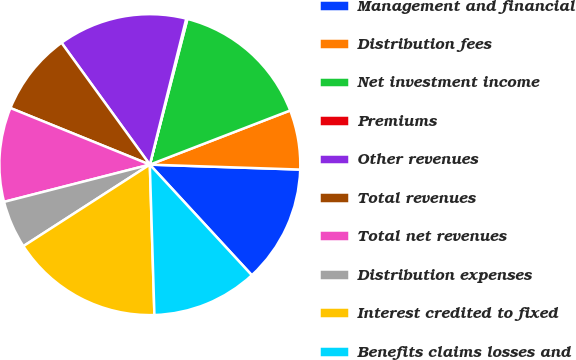Convert chart. <chart><loc_0><loc_0><loc_500><loc_500><pie_chart><fcel>Management and financial<fcel>Distribution fees<fcel>Net investment income<fcel>Premiums<fcel>Other revenues<fcel>Total revenues<fcel>Total net revenues<fcel>Distribution expenses<fcel>Interest credited to fixed<fcel>Benefits claims losses and<nl><fcel>12.62%<fcel>6.38%<fcel>15.12%<fcel>0.13%<fcel>13.87%<fcel>8.88%<fcel>10.12%<fcel>5.13%<fcel>16.37%<fcel>11.37%<nl></chart> 